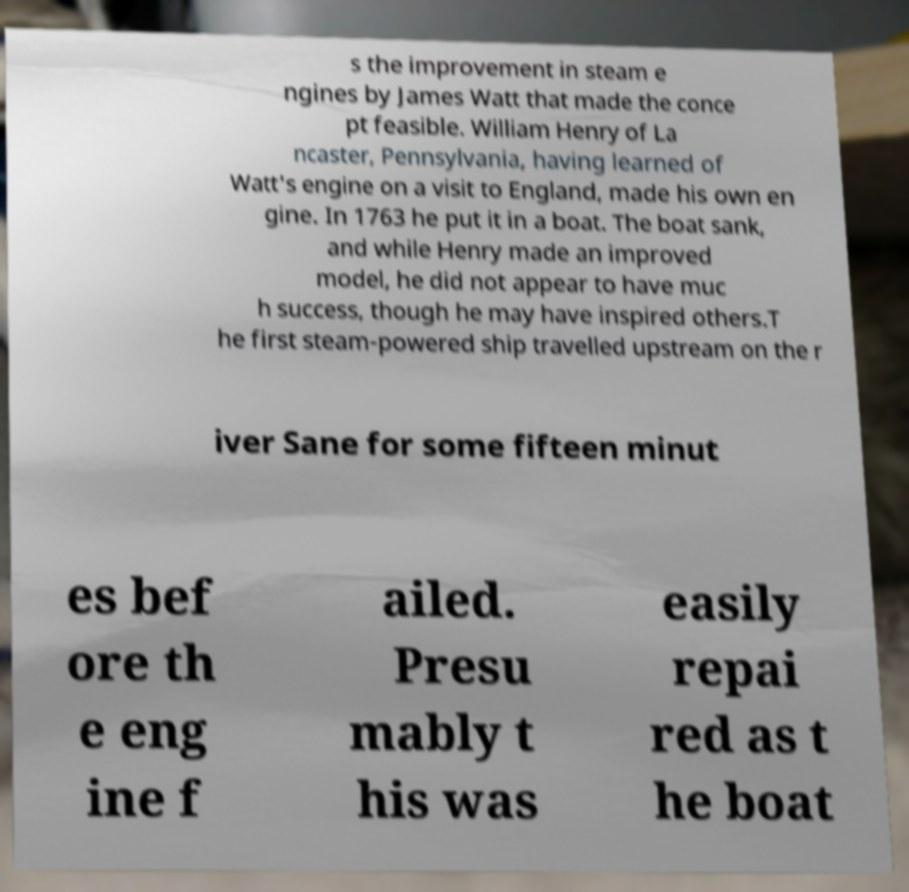Please read and relay the text visible in this image. What does it say? s the improvement in steam e ngines by James Watt that made the conce pt feasible. William Henry of La ncaster, Pennsylvania, having learned of Watt's engine on a visit to England, made his own en gine. In 1763 he put it in a boat. The boat sank, and while Henry made an improved model, he did not appear to have muc h success, though he may have inspired others.T he first steam-powered ship travelled upstream on the r iver Sane for some fifteen minut es bef ore th e eng ine f ailed. Presu mably t his was easily repai red as t he boat 